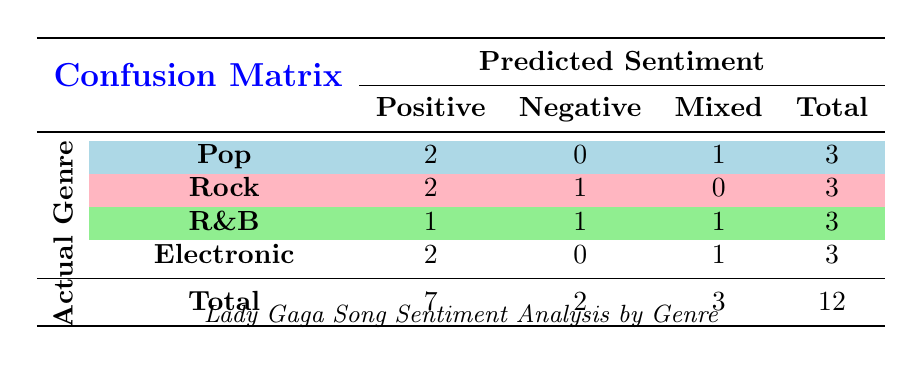What is the total number of songs analyzed across all genres? To find the total number of songs, we can look at the "Total" column at the bottom of the table. It indicates that there are 12 songs in total.
Answer: 12 How many songs in the Pop genre were classified as Positive? Referring to the Pop row in the table, there are 2 songs classified as Positive.
Answer: 2 What is the difference in the number of Positive songs between Pop and Rock genres? The number of Positive songs in Pop is 2 and in Rock is 2 as well. The difference is computed as 2 - 2 = 0.
Answer: 0 Is there any song classified as Negative in the Electronic genre? Looking at the Electronic row in the table, there are 0 songs classified as Negative.
Answer: No Which genre has the highest number of Mixed sentiment songs? By analyzing the Mixed sentiment column, both Pop and Electronic genres have 1 song each, whereas Rock has 0, and R&B has 1. So, the maximum count is 1, which is tied among Pop, R&B, and Electronic.
Answer: Pop, R&B, and Electronic What is the total number of Negative sentiment songs across all genres? To find the total number of Negative songs, we refer to the "Total" column for Negative sentiment, which shows there are 2 such songs in total.
Answer: 2 How many songs in the R&B genre are classified as Mixed? The R&B row indicates that there is 1 song classified as Mixed.
Answer: 1 What percentage of the total songs are classified as Positive? The total number of Positive songs is 7 (from the Total column) out of 12 total songs. The percentage is calculated as (7/12) * 100 = 58.33%.
Answer: 58.33% Which genre has the most total songs analyzed? Each genre has 3 songs, so the total is equal across all genres. Therefore, no specific genre has the most total songs; they are all tied.
Answer: All genres are tied 